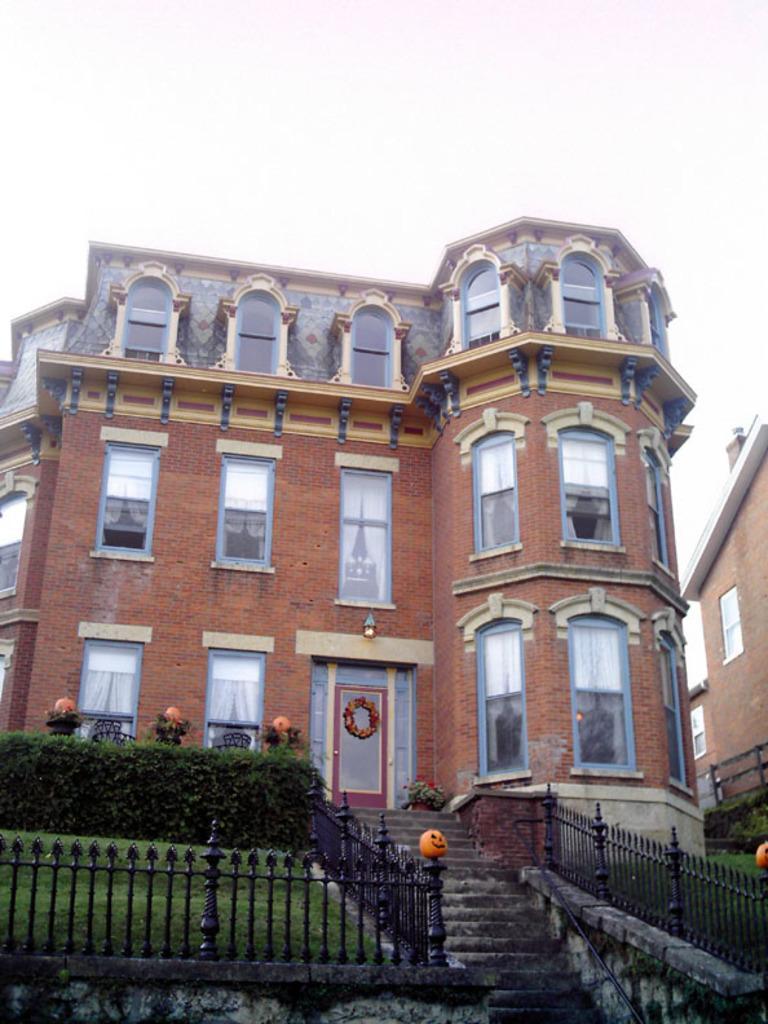Please provide a concise description of this image. In the background we can see the sky. In this picture we can see a building, windows, railings, plants, green grass, stairs and few objects. On the right side of the picture we can see the wall and windows. 